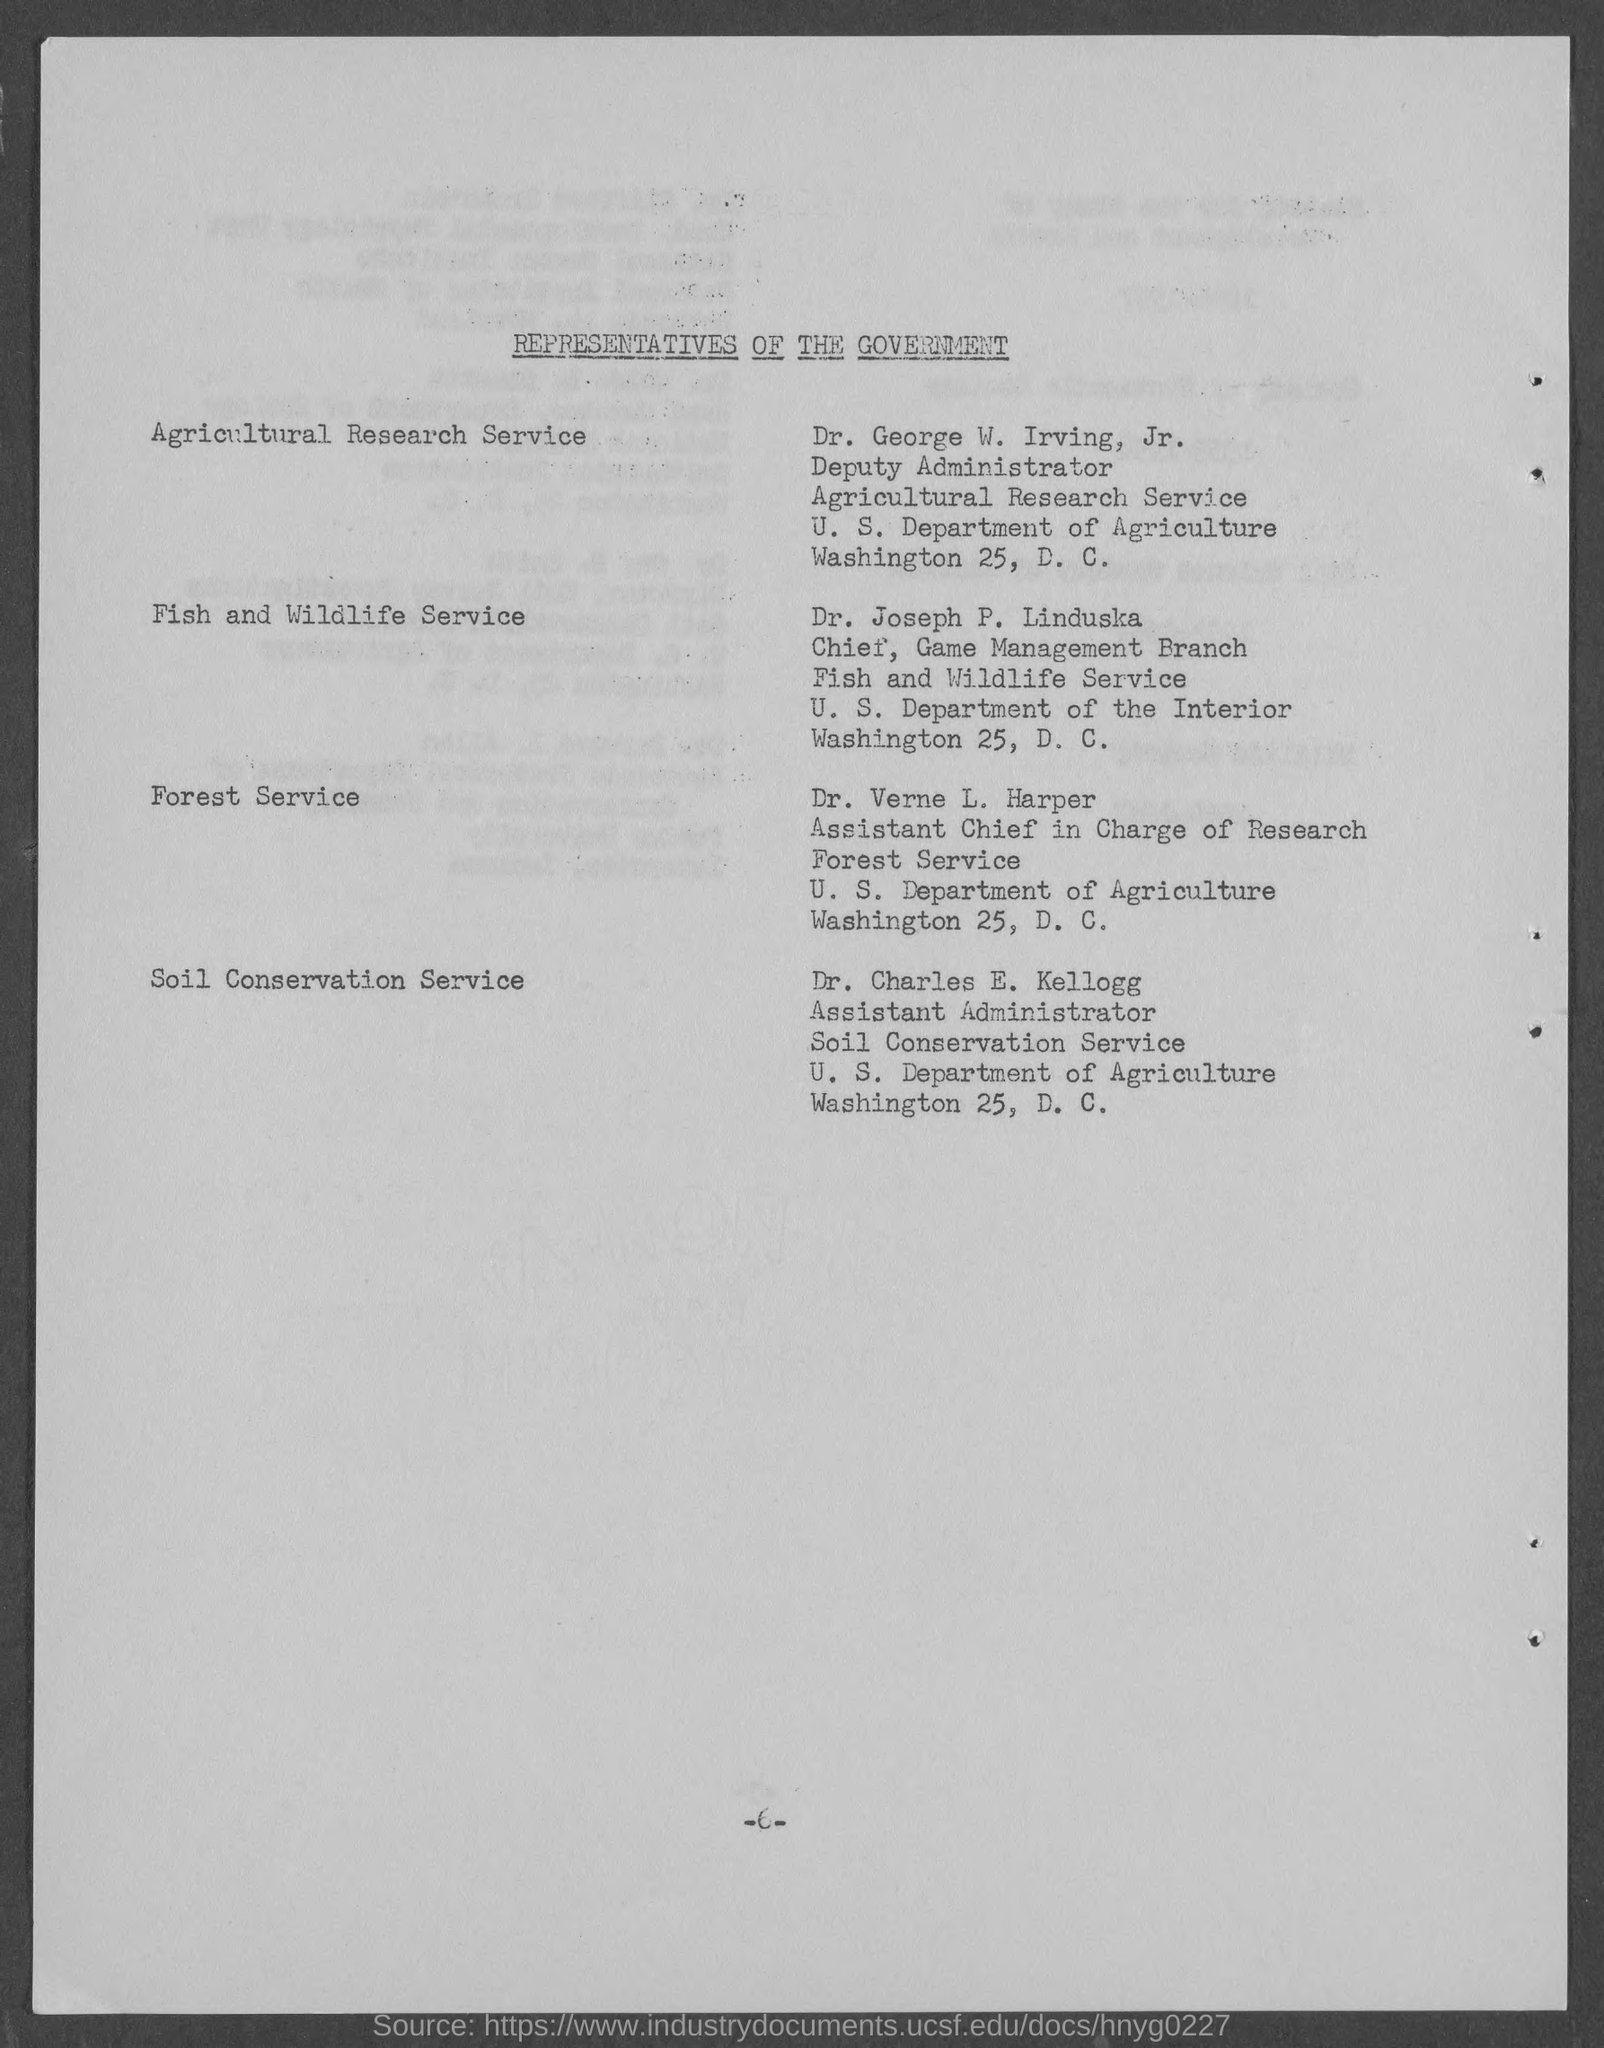Outline some significant characteristics in this image. Dr. George W. Irving, Jr., is the representative of the Agricultural Research Service. Dr. Verne L. Harper is an Assistant Chief of the Forest Service who is in charge of research. The document title is REPRESENTATIVES OF THE GOVERNMENT... The Assistant Administrator of the Soil Conservation Service is Dr. Charles E. Kellogg. 